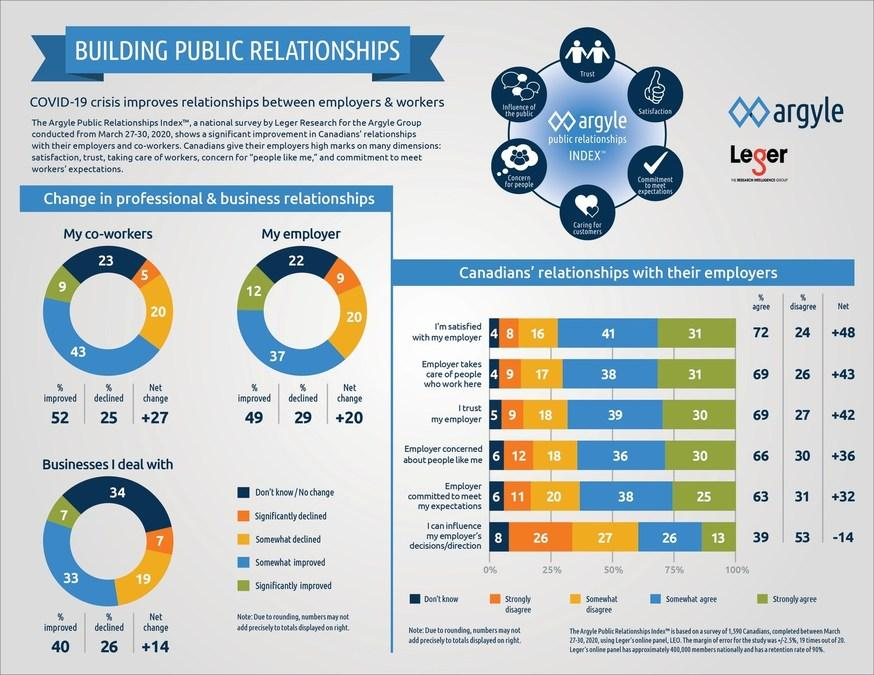Outline some significant characteristics in this image. According to a survey conducted from March 27-30, 2020, 26% of Canadians strongly disagree that they can influence their employer's decision. According to a survey conducted from March 27-30, 2020, a significant percentage of Canadians reported improvements in their relationship with their employer. The exact percentage was not provided in the question. According to a survey conducted from March 27-30, 2020, 30% of Canadians strongly agreed that they trust their employer. According to a survey conducted from March 27-30, 2020, a significant percentage of Canadians are unsure if their employer will provide care to their employees. According to a survey conducted from March 27-30, 2020, approximately 5% of Canadians reported a significant decline in their relationship with their co-workers. 